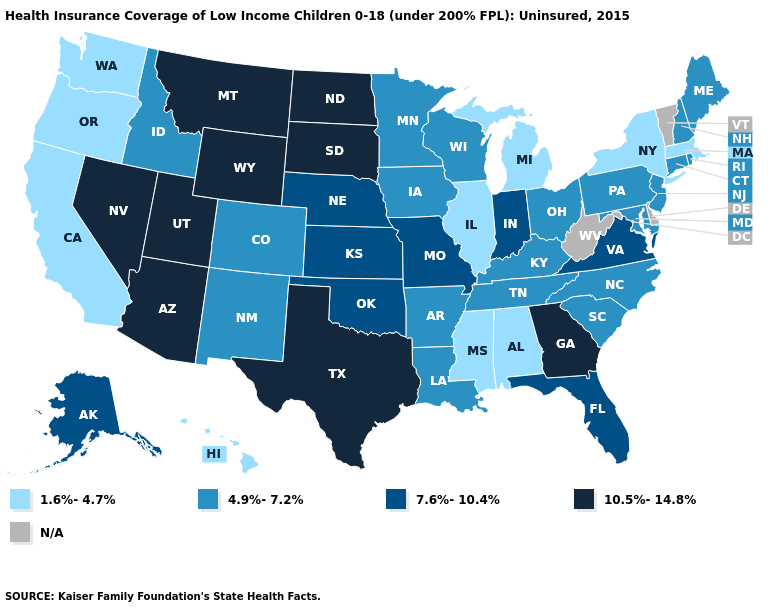What is the value of North Carolina?
Keep it brief. 4.9%-7.2%. Name the states that have a value in the range N/A?
Keep it brief. Delaware, Vermont, West Virginia. Name the states that have a value in the range 10.5%-14.8%?
Answer briefly. Arizona, Georgia, Montana, Nevada, North Dakota, South Dakota, Texas, Utah, Wyoming. Name the states that have a value in the range N/A?
Answer briefly. Delaware, Vermont, West Virginia. What is the highest value in the Northeast ?
Answer briefly. 4.9%-7.2%. Does Massachusetts have the highest value in the Northeast?
Be succinct. No. What is the highest value in the MidWest ?
Keep it brief. 10.5%-14.8%. What is the value of Nebraska?
Answer briefly. 7.6%-10.4%. What is the value of Minnesota?
Give a very brief answer. 4.9%-7.2%. Which states hav the highest value in the Northeast?
Keep it brief. Connecticut, Maine, New Hampshire, New Jersey, Pennsylvania, Rhode Island. Name the states that have a value in the range 7.6%-10.4%?
Write a very short answer. Alaska, Florida, Indiana, Kansas, Missouri, Nebraska, Oklahoma, Virginia. Among the states that border Tennessee , does Kentucky have the lowest value?
Give a very brief answer. No. What is the value of Mississippi?
Quick response, please. 1.6%-4.7%. Which states hav the highest value in the MidWest?
Short answer required. North Dakota, South Dakota. Which states have the highest value in the USA?
Be succinct. Arizona, Georgia, Montana, Nevada, North Dakota, South Dakota, Texas, Utah, Wyoming. 